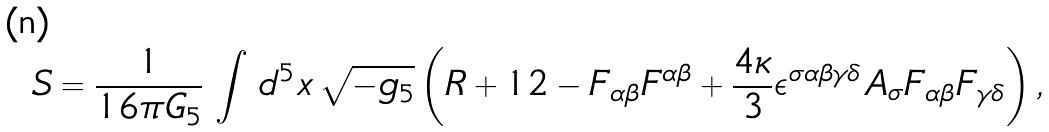Convert formula to latex. <formula><loc_0><loc_0><loc_500><loc_500>S = \frac { 1 } { 1 6 \pi G _ { 5 } } \, \int \, d ^ { 5 } x \, \sqrt { - g _ { 5 } } \left ( R + 1 2 - F _ { \alpha \beta } F ^ { \alpha \beta } + \frac { 4 \kappa } { 3 } \epsilon ^ { \sigma \alpha \beta \gamma \delta } A _ { \sigma } F _ { \alpha \beta } F _ { \gamma \delta } \right ) ,</formula> 